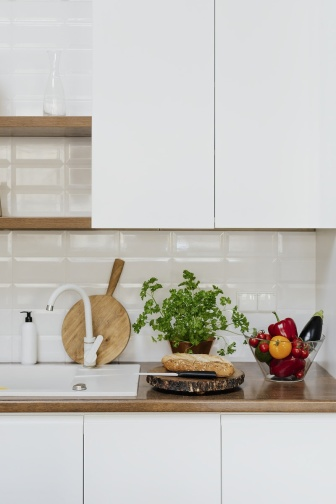Describe the following image. The image depicts a minimalist and modern kitchen. At the center, a sleek wooden countertop is adorned with a potted herb plant and a bowl brimming with fresh fruits, including vibrant red and yellow apples, bananas, and a few bell peppers. To the left, a white sink with a contemporary black faucet is visible. Atop a wooden cutting board are a loaf of bread and a white marble pestle and mortar, suggesting a space ready for culinary activities. The backdrop consists of crisp white subway tiles and white cabinets, providing a clean and serene atmosphere. The elements are thoughtfully arranged to create an aesthetic and functional space, exuding a sense of calm and organization. 